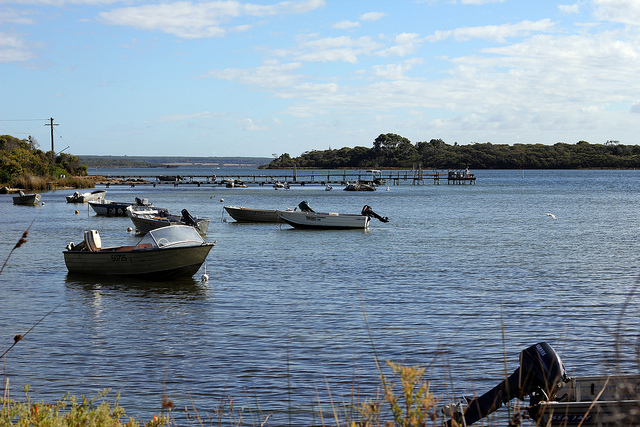If you could step into this scene, what details would you notice that aren't visible in the image? Stepping into this tranquil scene, you would feel the cool breeze gently brushing against your face, carrying with it the faint, refreshing scent of water. The sound of the boats softly creaking, accompanied by the distant calls of birds, would create a serene auditory backdrop. The grass and reeds along the shore would rustle softly in the wind, and you might notice small ripples forming on the lake's surface as fish break through momentarily. The warmth of the sun filtering through the clouds would add a comforting touch, making this serene environment feel even more welcoming and idyllic. 